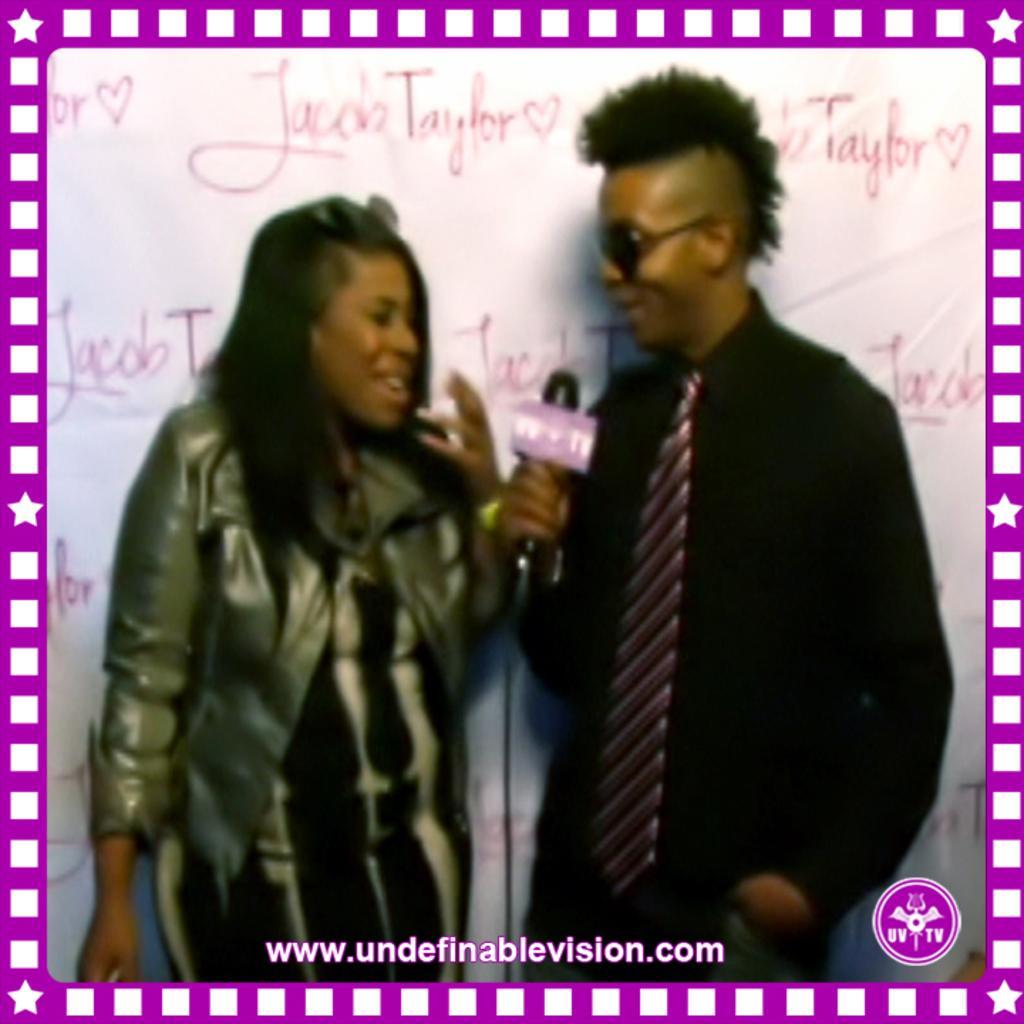Who is present in the image? There is a lady and a guy in the image. What is the lady wearing? The lady is wearing a jacket. What is the guy wearing? The guy is wearing a black shirt and tie. What is the guy holding in the image? The guy is holding a mic. What can be seen on the wall in the background? There are things written on the wall in the background. What type of crate is visible in the image? There is no crate present in the image. What is the source of amusement in the image? The image does not depict a specific source of amusement; it features a lady and a guy with a mic. 